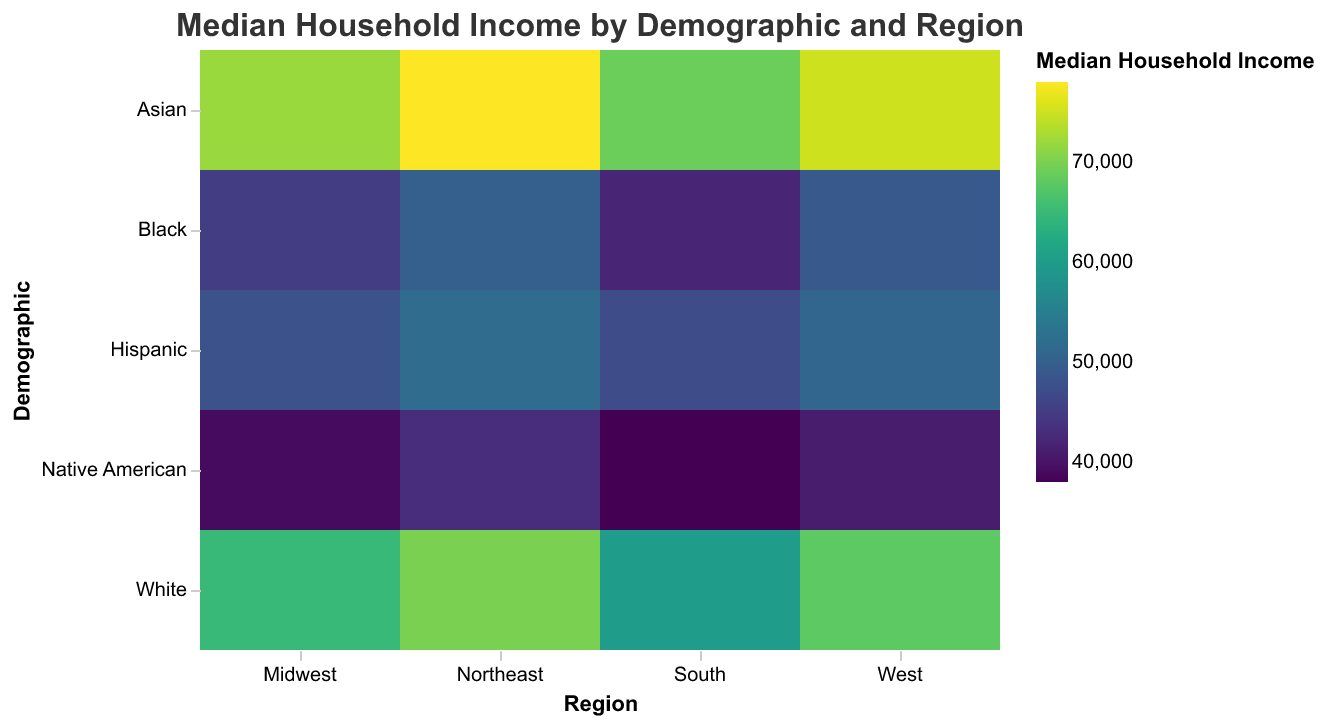What is the title of the heatmap? The title of the heatmap is located at the top of the figure and provides a summary of what the data represents. Here it is written as text.
Answer: Median Household Income by Demographic and Region What are the x-axis and y-axis labels? The labels for the x-axis and y-axis help identify the variables that are being plotted. In this case, the x-axis is labeled "Region" and the y-axis is labeled "Demographic."
Answer: "Region" and "Demographic" Which demographic has the lowest median household income in the Midwest region? To identify this, look at the Midwest column on the x-axis and scan down to find the lowest value. The demographic associated with this value is Native American with $39,000.
Answer: Native American What is the median household income for Asians in the Northeast? Locate the intersection of the Northeast column and the Asian row. The value at this intersection represents the median household income, which is $78,000.
Answer: $78,000 Which region has the highest median household income for Whites? Analyze all the values across the four regions (Midwest, South, Northeast, West) for the demographic 'White'. The highest value is $70,000 in the Northeast.
Answer: Northeast What is the difference in median household income between Hispanics and Blacks in the South? Locate the median household income values for Hispanics and Blacks in the South region, which are $47,000 and $42,000 respectively. Subtract the two values to find the difference: 47,000 - 42,000 = $5,000.
Answer: $5,000 Which demographic shows the most significant income disparity across the regions? To determine this, compare the range of median household incomes for each demographic across all regions. Asians have the highest disparity, ranging from $69,000 in the South to $78,000 in the Northeast, a difference of $9,000.
Answer: Asians What is the average median household income for Native Americans across all regions? Sum the median household incomes for Native Americans in all regions: 39000 + 38000 + 43000 + 41000 = 161000. Then divide by the number of regions (4): 161000 / 4 = $40,250.
Answer: $40,250 Does any region show a consistent trend of being higher or lower across all demographics? By examining the heatmap, note the income levels for each demographic in each region. The Northeast generally shows higher median household incomes across multiple demographics when compared to other regions.
Answer: Northeast Which demographic has the smallest variation in median household income across regions? Look at the differences in incomes for each demographic across the four regions. Hispanics have the smallest variation, ranging from $47,000 to $52,000, a difference of $5,000.
Answer: Hispanics 